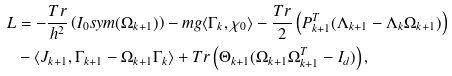<formula> <loc_0><loc_0><loc_500><loc_500>L & = - \frac { T r } { h ^ { 2 } } \left ( I _ { 0 } s y m ( \Omega _ { k + 1 } ) \right ) - m g \langle \Gamma _ { k } , \chi _ { 0 } \rangle - \frac { T r } { 2 } \left ( P _ { k + 1 } ^ { T } ( \Lambda _ { k + 1 } - \Lambda _ { k } \Omega _ { k + 1 } ) \right ) \\ & - \langle J _ { k + 1 } , \Gamma _ { k + 1 } - \Omega _ { k + 1 } \Gamma _ { k } \rangle + T r \left ( \Theta _ { k + 1 } ( \Omega _ { k + 1 } \Omega _ { k + 1 } ^ { T } - I _ { d } ) \right ) ,</formula> 